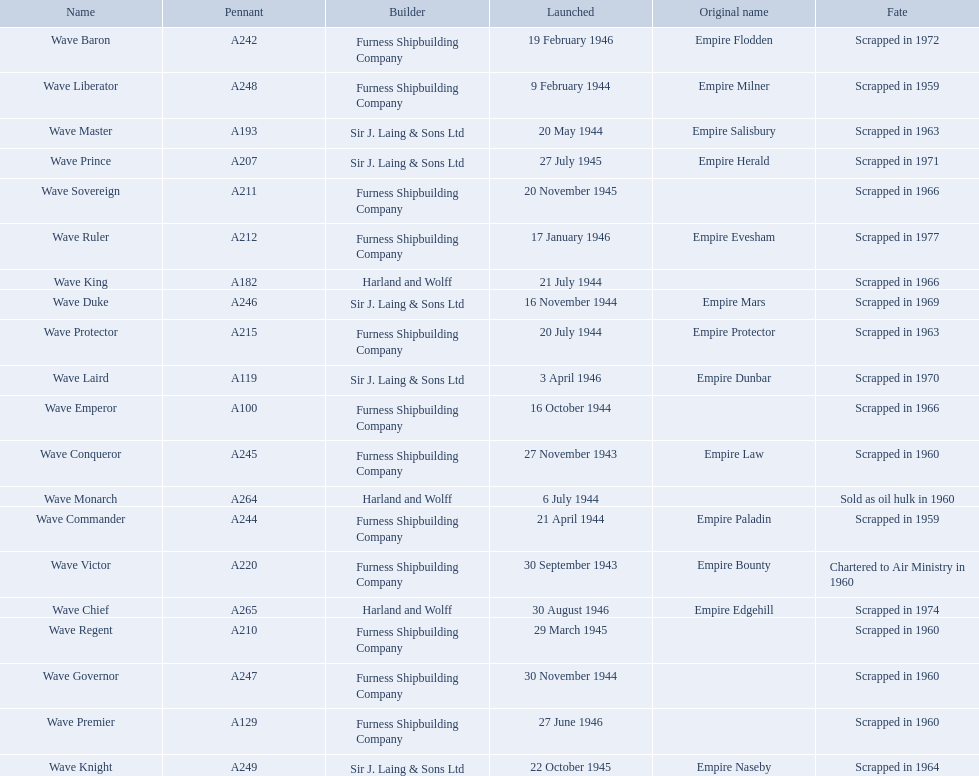What builders launched ships in november of any year? Furness Shipbuilding Company, Sir J. Laing & Sons Ltd, Furness Shipbuilding Company, Furness Shipbuilding Company. What ship builders ships had their original name's changed prior to scrapping? Furness Shipbuilding Company, Sir J. Laing & Sons Ltd. What was the name of the ship that was built in november and had its name changed prior to scrapping only 12 years after its launch? Wave Conqueror. What year was the wave victor launched? 30 September 1943. What other ship was launched in 1943? Wave Conqueror. 